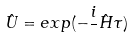<formula> <loc_0><loc_0><loc_500><loc_500>\hat { U } = e x p ( - \frac { i } { } \hat { H } \tau )</formula> 